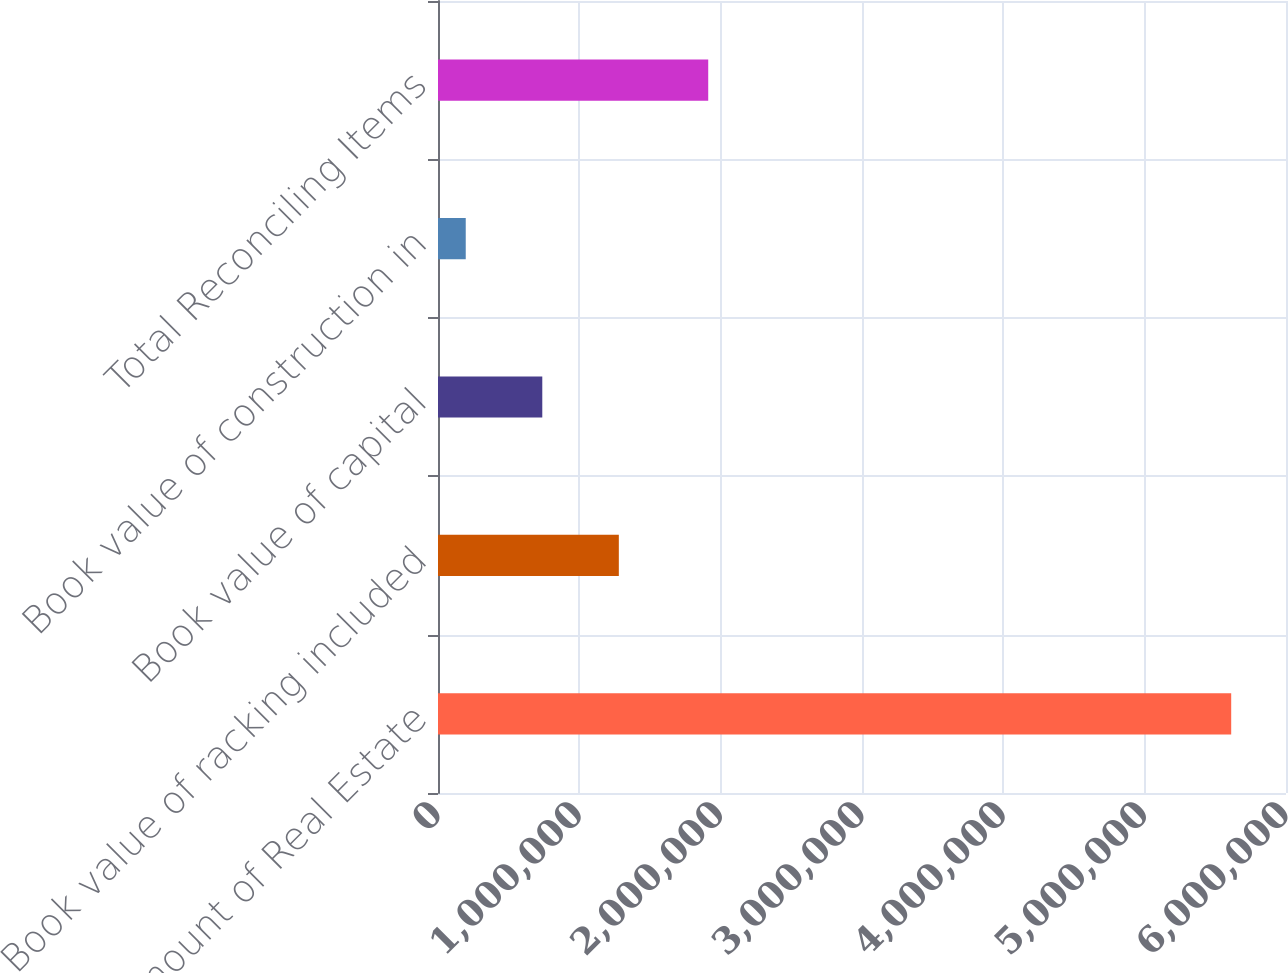<chart> <loc_0><loc_0><loc_500><loc_500><bar_chart><fcel>Gross Amount of Real Estate<fcel>Book value of racking included<fcel>Book value of capital<fcel>Book value of construction in<fcel>Total Reconciling Items<nl><fcel>5.61228e+06<fcel>1.27947e+06<fcel>737869<fcel>196268<fcel>1.91197e+06<nl></chart> 